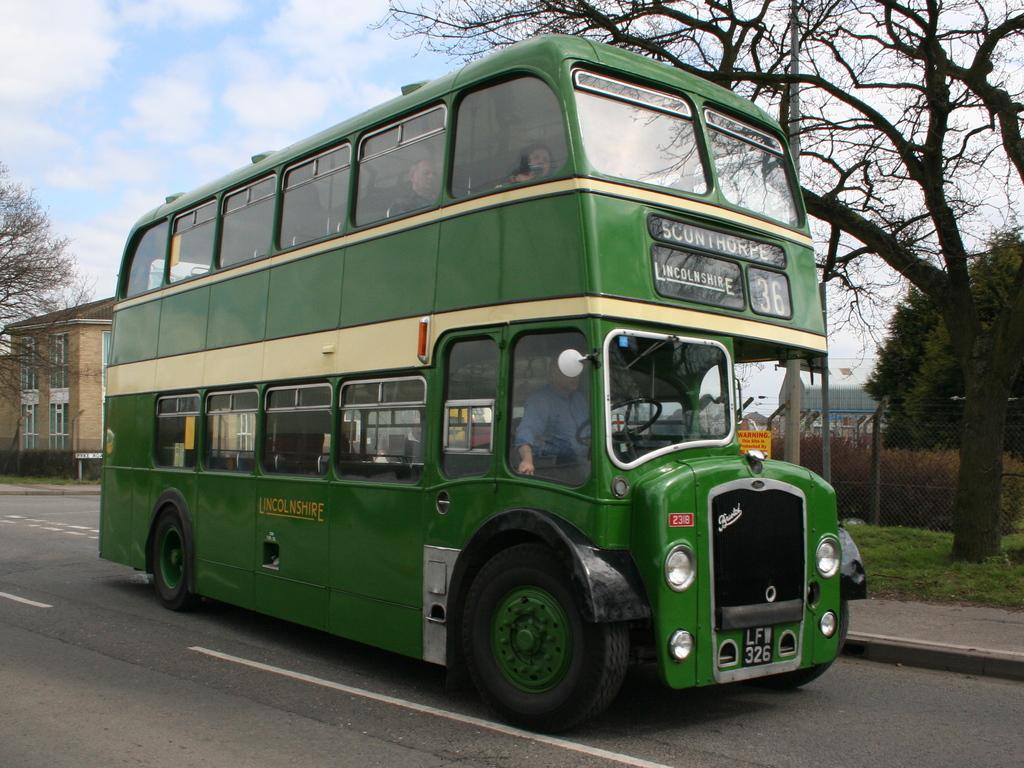<image>
Summarize the visual content of the image. A green double decker bus headed to Lincolnshire with the number 36. 